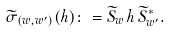Convert formula to latex. <formula><loc_0><loc_0><loc_500><loc_500>\widetilde { \sigma } _ { ( w , w ^ { \prime } ) } ( h ) \colon = \widetilde { S } _ { w } \, h \, \widetilde { S } _ { w ^ { \prime } } ^ { * } .</formula> 